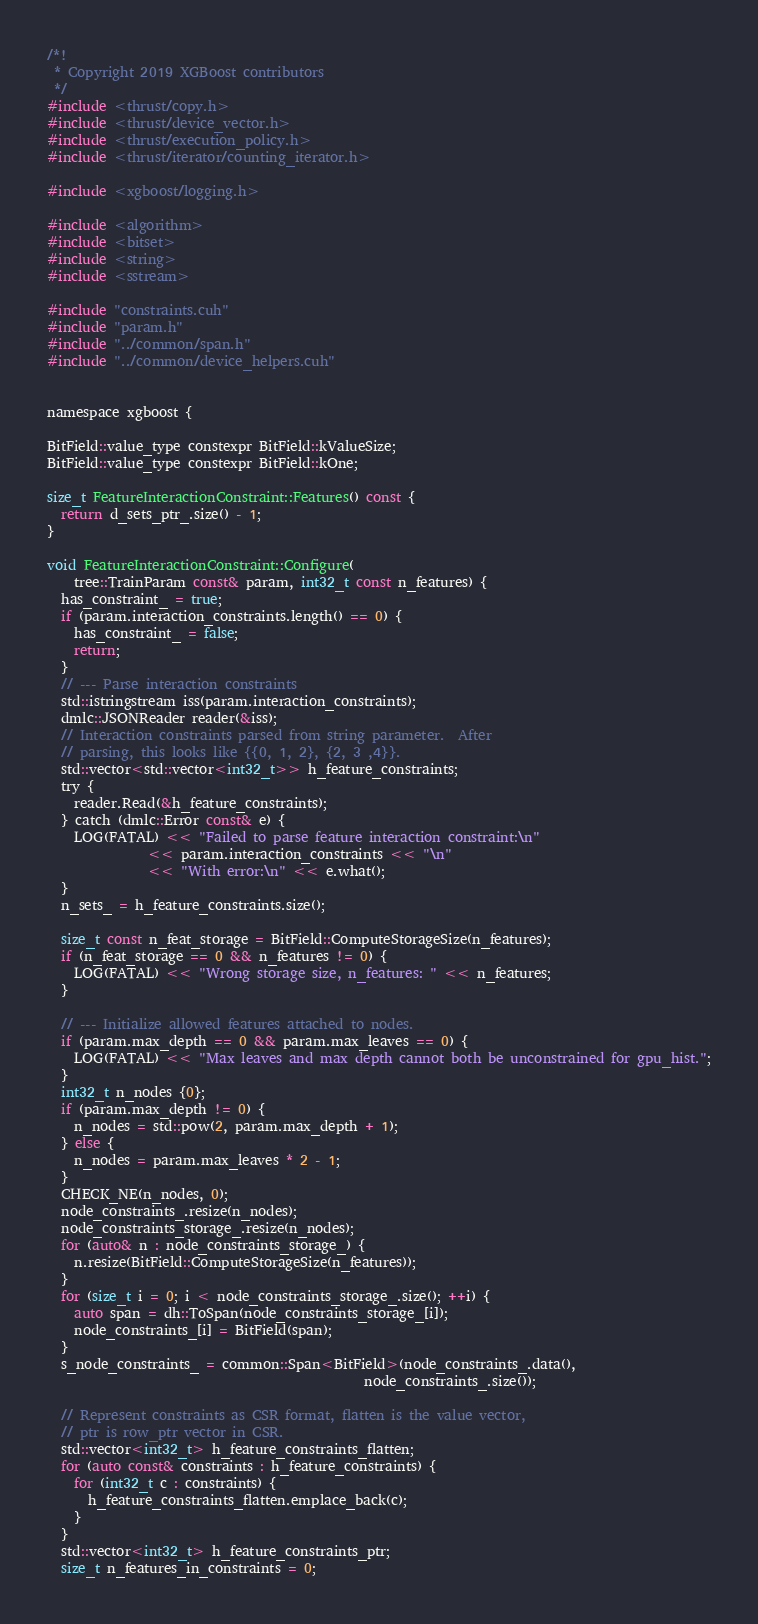Convert code to text. <code><loc_0><loc_0><loc_500><loc_500><_Cuda_>/*!
 * Copyright 2019 XGBoost contributors
 */
#include <thrust/copy.h>
#include <thrust/device_vector.h>
#include <thrust/execution_policy.h>
#include <thrust/iterator/counting_iterator.h>

#include <xgboost/logging.h>

#include <algorithm>
#include <bitset>
#include <string>
#include <sstream>

#include "constraints.cuh"
#include "param.h"
#include "../common/span.h"
#include "../common/device_helpers.cuh"


namespace xgboost {

BitField::value_type constexpr BitField::kValueSize;
BitField::value_type constexpr BitField::kOne;

size_t FeatureInteractionConstraint::Features() const {
  return d_sets_ptr_.size() - 1;
}

void FeatureInteractionConstraint::Configure(
    tree::TrainParam const& param, int32_t const n_features) {
  has_constraint_ = true;
  if (param.interaction_constraints.length() == 0) {
    has_constraint_ = false;
    return;
  }
  // --- Parse interaction constraints
  std::istringstream iss(param.interaction_constraints);
  dmlc::JSONReader reader(&iss);
  // Interaction constraints parsed from string parameter.  After
  // parsing, this looks like {{0, 1, 2}, {2, 3 ,4}}.
  std::vector<std::vector<int32_t>> h_feature_constraints;
  try {
    reader.Read(&h_feature_constraints);
  } catch (dmlc::Error const& e) {
    LOG(FATAL) << "Failed to parse feature interaction constraint:\n"
               << param.interaction_constraints << "\n"
               << "With error:\n" << e.what();
  }
  n_sets_ = h_feature_constraints.size();

  size_t const n_feat_storage = BitField::ComputeStorageSize(n_features);
  if (n_feat_storage == 0 && n_features != 0) {
    LOG(FATAL) << "Wrong storage size, n_features: " << n_features;
  }

  // --- Initialize allowed features attached to nodes.
  if (param.max_depth == 0 && param.max_leaves == 0) {
    LOG(FATAL) << "Max leaves and max depth cannot both be unconstrained for gpu_hist.";
  }
  int32_t n_nodes {0};
  if (param.max_depth != 0) {
    n_nodes = std::pow(2, param.max_depth + 1);
  } else {
    n_nodes = param.max_leaves * 2 - 1;
  }
  CHECK_NE(n_nodes, 0);
  node_constraints_.resize(n_nodes);
  node_constraints_storage_.resize(n_nodes);
  for (auto& n : node_constraints_storage_) {
    n.resize(BitField::ComputeStorageSize(n_features));
  }
  for (size_t i = 0; i < node_constraints_storage_.size(); ++i) {
    auto span = dh::ToSpan(node_constraints_storage_[i]);
    node_constraints_[i] = BitField(span);
  }
  s_node_constraints_ = common::Span<BitField>(node_constraints_.data(),
                                               node_constraints_.size());

  // Represent constraints as CSR format, flatten is the value vector,
  // ptr is row_ptr vector in CSR.
  std::vector<int32_t> h_feature_constraints_flatten;
  for (auto const& constraints : h_feature_constraints) {
    for (int32_t c : constraints) {
      h_feature_constraints_flatten.emplace_back(c);
    }
  }
  std::vector<int32_t> h_feature_constraints_ptr;
  size_t n_features_in_constraints = 0;</code> 